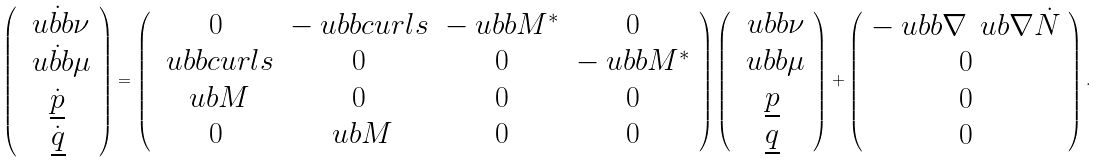Convert formula to latex. <formula><loc_0><loc_0><loc_500><loc_500>\left ( \begin{array} { c } \dot { \ u b b \nu } \\ \dot { \ u b b \mu } \\ \dot { \underline { p } } \\ \dot { \underline { q } } \end{array} \right ) = \left ( \begin{array} { c c c c } 0 & - \ u b b c u r l s & - \ u b b M ^ { * } & 0 \\ \ u b b c u r l s & 0 & 0 & - \ u b b M ^ { * } \\ \ u b M & 0 & 0 & 0 \\ 0 & \ u b M & 0 & 0 \end{array} \right ) \left ( \begin{array} { c } \ u b b \nu \\ \ u b b \mu \\ \underline { p } \\ \underline { q } \end{array} \right ) + \left ( \begin{array} { c } - \ u b b \nabla \, \ u b \nabla \dot { N } \\ 0 \\ 0 \\ 0 \end{array} \right ) .</formula> 